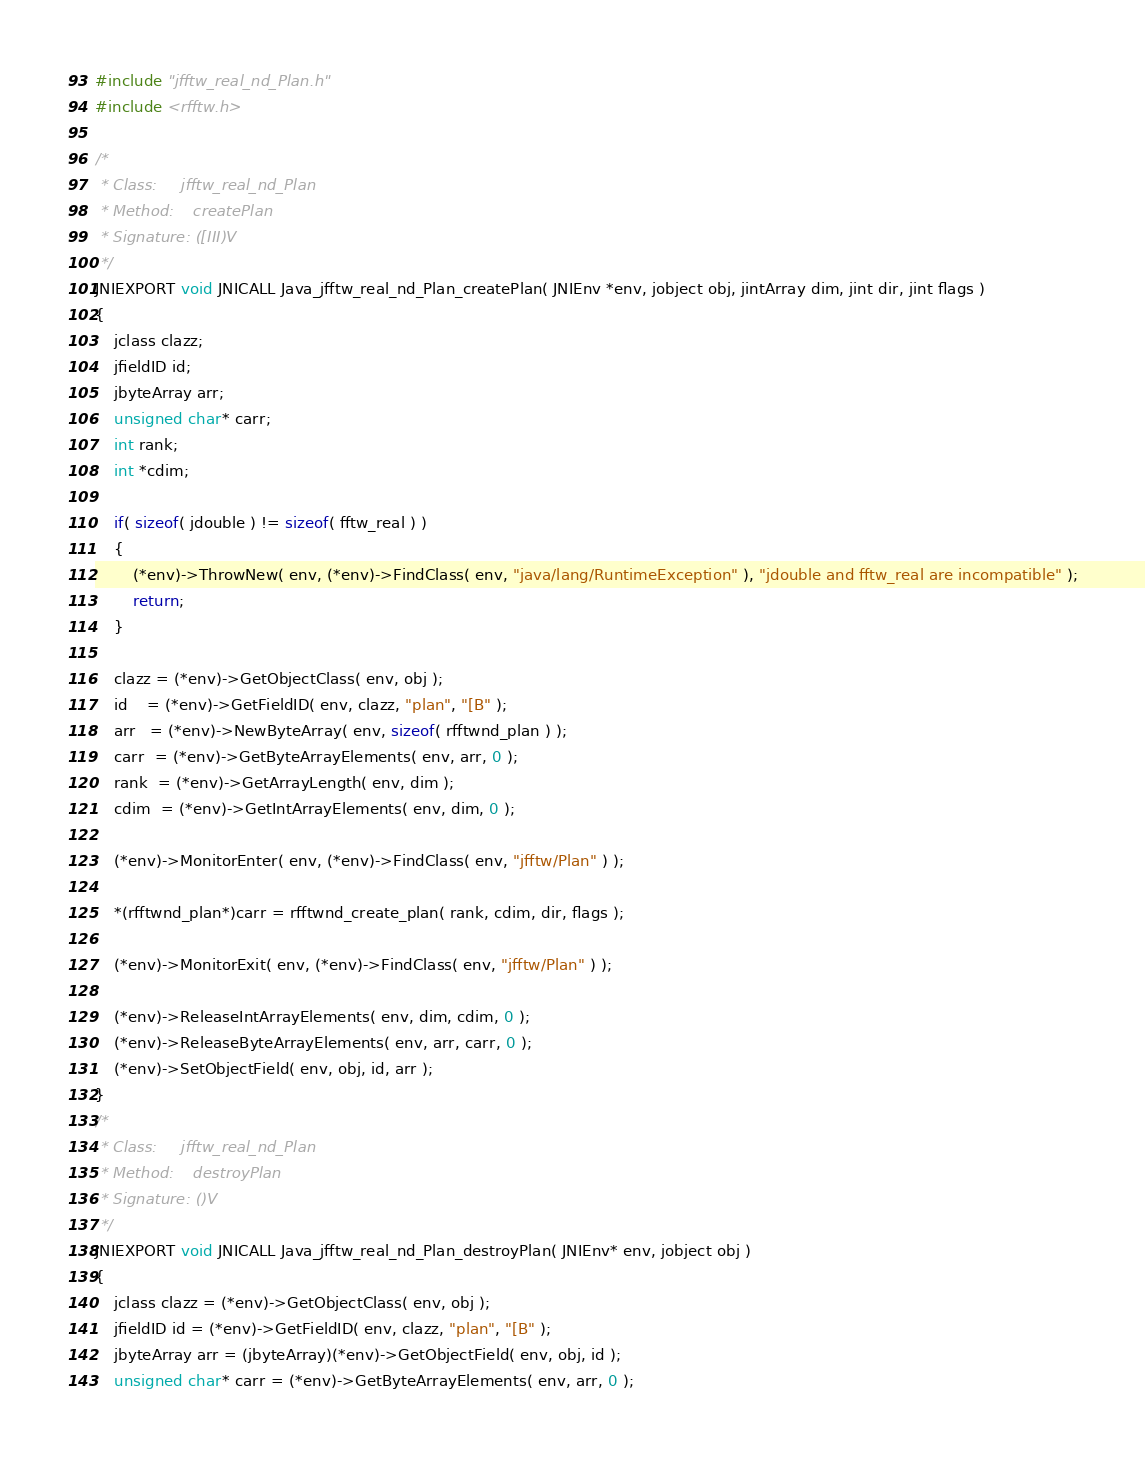Convert code to text. <code><loc_0><loc_0><loc_500><loc_500><_C_>#include "jfftw_real_nd_Plan.h"
#include <rfftw.h>

/*
 * Class:     jfftw_real_nd_Plan
 * Method:    createPlan
 * Signature: ([III)V
 */
JNIEXPORT void JNICALL Java_jfftw_real_nd_Plan_createPlan( JNIEnv *env, jobject obj, jintArray dim, jint dir, jint flags )
{
	jclass clazz;
	jfieldID id;
	jbyteArray arr;
	unsigned char* carr;
	int rank;
	int *cdim;

	if( sizeof( jdouble ) != sizeof( fftw_real ) )
	{
		(*env)->ThrowNew( env, (*env)->FindClass( env, "java/lang/RuntimeException" ), "jdouble and fftw_real are incompatible" );
		return;
	}

	clazz = (*env)->GetObjectClass( env, obj );
	id    = (*env)->GetFieldID( env, clazz, "plan", "[B" );
	arr   = (*env)->NewByteArray( env, sizeof( rfftwnd_plan ) );
	carr  = (*env)->GetByteArrayElements( env, arr, 0 );
	rank  = (*env)->GetArrayLength( env, dim );
	cdim  = (*env)->GetIntArrayElements( env, dim, 0 );

	(*env)->MonitorEnter( env, (*env)->FindClass( env, "jfftw/Plan" ) );

	*(rfftwnd_plan*)carr = rfftwnd_create_plan( rank, cdim, dir, flags );

	(*env)->MonitorExit( env, (*env)->FindClass( env, "jfftw/Plan" ) );

	(*env)->ReleaseIntArrayElements( env, dim, cdim, 0 );
	(*env)->ReleaseByteArrayElements( env, arr, carr, 0 );
	(*env)->SetObjectField( env, obj, id, arr );
}
/*
 * Class:     jfftw_real_nd_Plan
 * Method:    destroyPlan
 * Signature: ()V
 */
JNIEXPORT void JNICALL Java_jfftw_real_nd_Plan_destroyPlan( JNIEnv* env, jobject obj )
{
	jclass clazz = (*env)->GetObjectClass( env, obj );
	jfieldID id = (*env)->GetFieldID( env, clazz, "plan", "[B" );
	jbyteArray arr = (jbyteArray)(*env)->GetObjectField( env, obj, id );
	unsigned char* carr = (*env)->GetByteArrayElements( env, arr, 0 );
</code> 